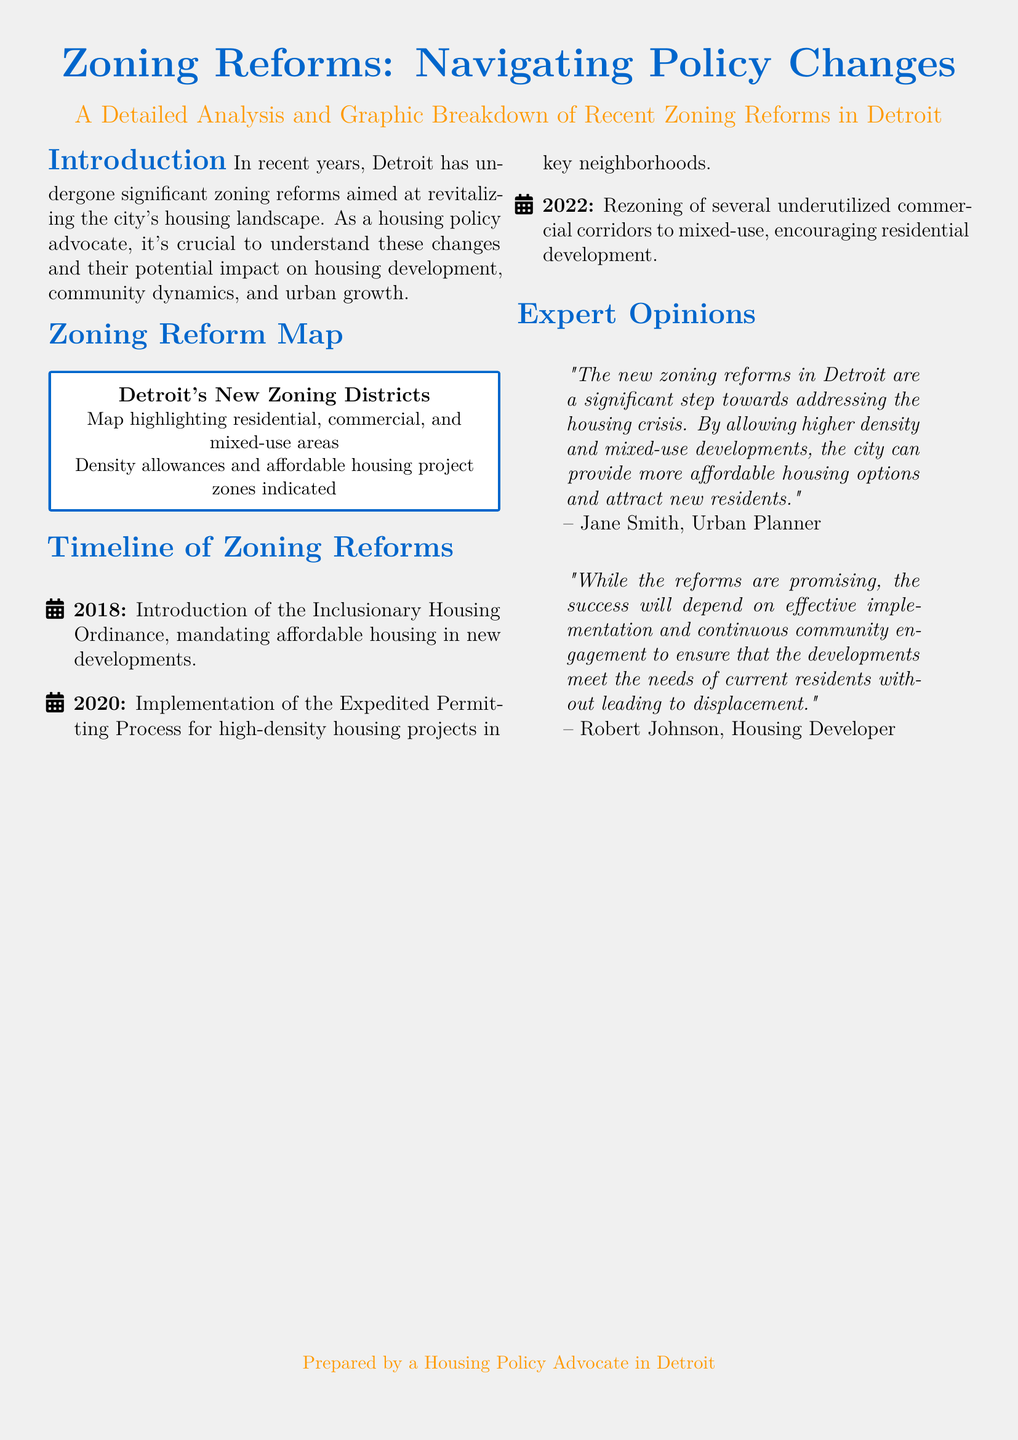What is the name of the ordinance introduced in 2018? The ordinance introduced in 2018 is the Inclusionary Housing Ordinance, which mandates affordable housing in new developments.
Answer: Inclusionary Housing Ordinance What year did the expedited permitting process get implemented? The expedited permitting process for high-density housing projects was implemented in 2020.
Answer: 2020 What type of map is included in the document? The document includes a map highlighting residential, commercial, and mixed-use areas, along with density allowances and affordable housing project zones.
Answer: Zoning Districts Map Who provided the opinion stating that the zoning reforms are a significant step towards addressing the housing crisis? The opinion was provided by Jane Smith, an Urban Planner.
Answer: Jane Smith What is a key aspect of the 2022 zoning reforms? The key aspect is the rezoning of several underutilized commercial corridors to mixed-use, which encourages residential development.
Answer: Mixed-use rezoning What is essential for the success of the zoning reforms according to Robert Johnson? According to Robert Johnson, effective implementation and continuous community engagement are essential for the success of the zoning reforms.
Answer: Effective implementation How many zoning reform events are documented in the timeline? There are three zoning reform events documented in the timeline.
Answer: Three What does the introduction emphasize as crucial for understanding the zoning changes? The introduction emphasizes understanding the impact of zoning changes on housing development, community dynamics, and urban growth.
Answer: Understanding impacts 